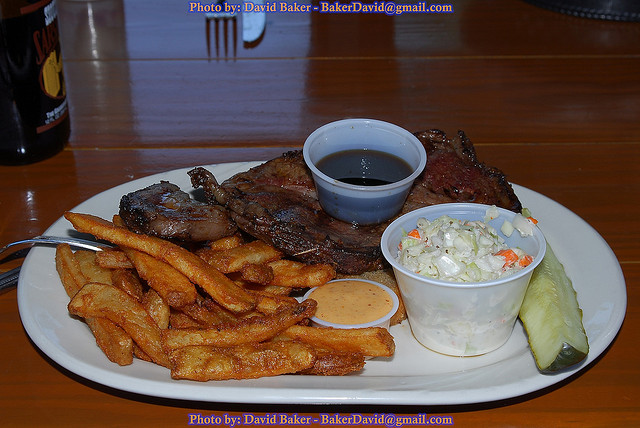Extract all visible text content from this image. Photo by David Baker BakerDavid@gmail.com -BakerDacid@gailm.com Baker David by Photo 